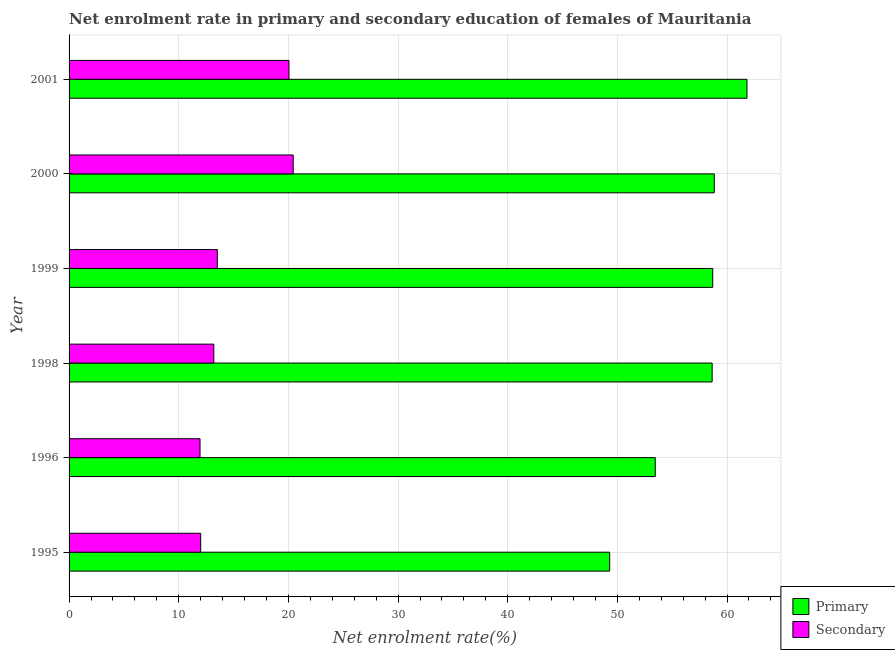Are the number of bars on each tick of the Y-axis equal?
Offer a terse response. Yes. How many bars are there on the 6th tick from the top?
Make the answer very short. 2. What is the label of the 3rd group of bars from the top?
Make the answer very short. 1999. In how many cases, is the number of bars for a given year not equal to the number of legend labels?
Provide a short and direct response. 0. What is the enrollment rate in primary education in 2000?
Provide a short and direct response. 58.84. Across all years, what is the maximum enrollment rate in primary education?
Provide a short and direct response. 61.82. Across all years, what is the minimum enrollment rate in secondary education?
Make the answer very short. 11.94. In which year was the enrollment rate in primary education maximum?
Offer a very short reply. 2001. In which year was the enrollment rate in primary education minimum?
Give a very brief answer. 1995. What is the total enrollment rate in secondary education in the graph?
Provide a short and direct response. 91.15. What is the difference between the enrollment rate in secondary education in 1999 and that in 2001?
Ensure brevity in your answer.  -6.54. What is the difference between the enrollment rate in primary education in 1999 and the enrollment rate in secondary education in 2001?
Offer a very short reply. 38.64. What is the average enrollment rate in primary education per year?
Offer a terse response. 56.79. In the year 1996, what is the difference between the enrollment rate in primary education and enrollment rate in secondary education?
Provide a succinct answer. 41.51. What is the ratio of the enrollment rate in secondary education in 2000 to that in 2001?
Give a very brief answer. 1.02. Is the enrollment rate in primary education in 1995 less than that in 2000?
Make the answer very short. Yes. What is the difference between the highest and the second highest enrollment rate in secondary education?
Offer a very short reply. 0.38. What is the difference between the highest and the lowest enrollment rate in primary education?
Make the answer very short. 12.52. In how many years, is the enrollment rate in secondary education greater than the average enrollment rate in secondary education taken over all years?
Ensure brevity in your answer.  2. What does the 2nd bar from the top in 1998 represents?
Offer a very short reply. Primary. What does the 2nd bar from the bottom in 2001 represents?
Offer a terse response. Secondary. How many bars are there?
Keep it short and to the point. 12. Are all the bars in the graph horizontal?
Offer a very short reply. Yes. How many years are there in the graph?
Offer a very short reply. 6. What is the difference between two consecutive major ticks on the X-axis?
Make the answer very short. 10. Where does the legend appear in the graph?
Provide a succinct answer. Bottom right. How many legend labels are there?
Your answer should be very brief. 2. What is the title of the graph?
Your answer should be very brief. Net enrolment rate in primary and secondary education of females of Mauritania. Does "GDP" appear as one of the legend labels in the graph?
Offer a very short reply. No. What is the label or title of the X-axis?
Your answer should be compact. Net enrolment rate(%). What is the Net enrolment rate(%) in Primary in 1995?
Keep it short and to the point. 49.3. What is the Net enrolment rate(%) of Secondary in 1995?
Provide a succinct answer. 12. What is the Net enrolment rate(%) in Primary in 1996?
Your answer should be compact. 53.45. What is the Net enrolment rate(%) of Secondary in 1996?
Your response must be concise. 11.94. What is the Net enrolment rate(%) of Primary in 1998?
Your response must be concise. 58.64. What is the Net enrolment rate(%) in Secondary in 1998?
Your answer should be very brief. 13.2. What is the Net enrolment rate(%) in Primary in 1999?
Your answer should be very brief. 58.69. What is the Net enrolment rate(%) of Secondary in 1999?
Keep it short and to the point. 13.52. What is the Net enrolment rate(%) in Primary in 2000?
Your response must be concise. 58.84. What is the Net enrolment rate(%) of Secondary in 2000?
Your answer should be compact. 20.44. What is the Net enrolment rate(%) in Primary in 2001?
Keep it short and to the point. 61.82. What is the Net enrolment rate(%) in Secondary in 2001?
Keep it short and to the point. 20.05. Across all years, what is the maximum Net enrolment rate(%) in Primary?
Your answer should be very brief. 61.82. Across all years, what is the maximum Net enrolment rate(%) in Secondary?
Provide a short and direct response. 20.44. Across all years, what is the minimum Net enrolment rate(%) in Primary?
Keep it short and to the point. 49.3. Across all years, what is the minimum Net enrolment rate(%) of Secondary?
Offer a very short reply. 11.94. What is the total Net enrolment rate(%) of Primary in the graph?
Provide a succinct answer. 340.73. What is the total Net enrolment rate(%) of Secondary in the graph?
Offer a very short reply. 91.15. What is the difference between the Net enrolment rate(%) in Primary in 1995 and that in 1996?
Give a very brief answer. -4.16. What is the difference between the Net enrolment rate(%) in Secondary in 1995 and that in 1996?
Offer a terse response. 0.06. What is the difference between the Net enrolment rate(%) of Primary in 1995 and that in 1998?
Your response must be concise. -9.34. What is the difference between the Net enrolment rate(%) in Secondary in 1995 and that in 1998?
Provide a succinct answer. -1.2. What is the difference between the Net enrolment rate(%) of Primary in 1995 and that in 1999?
Give a very brief answer. -9.4. What is the difference between the Net enrolment rate(%) of Secondary in 1995 and that in 1999?
Offer a very short reply. -1.51. What is the difference between the Net enrolment rate(%) of Primary in 1995 and that in 2000?
Keep it short and to the point. -9.54. What is the difference between the Net enrolment rate(%) in Secondary in 1995 and that in 2000?
Offer a very short reply. -8.44. What is the difference between the Net enrolment rate(%) of Primary in 1995 and that in 2001?
Make the answer very short. -12.52. What is the difference between the Net enrolment rate(%) of Secondary in 1995 and that in 2001?
Your response must be concise. -8.05. What is the difference between the Net enrolment rate(%) in Primary in 1996 and that in 1998?
Offer a terse response. -5.19. What is the difference between the Net enrolment rate(%) of Secondary in 1996 and that in 1998?
Give a very brief answer. -1.26. What is the difference between the Net enrolment rate(%) of Primary in 1996 and that in 1999?
Ensure brevity in your answer.  -5.24. What is the difference between the Net enrolment rate(%) of Secondary in 1996 and that in 1999?
Provide a short and direct response. -1.57. What is the difference between the Net enrolment rate(%) in Primary in 1996 and that in 2000?
Provide a succinct answer. -5.38. What is the difference between the Net enrolment rate(%) in Secondary in 1996 and that in 2000?
Offer a very short reply. -8.49. What is the difference between the Net enrolment rate(%) in Primary in 1996 and that in 2001?
Your response must be concise. -8.36. What is the difference between the Net enrolment rate(%) of Secondary in 1996 and that in 2001?
Your answer should be compact. -8.11. What is the difference between the Net enrolment rate(%) in Primary in 1998 and that in 1999?
Make the answer very short. -0.05. What is the difference between the Net enrolment rate(%) in Secondary in 1998 and that in 1999?
Keep it short and to the point. -0.32. What is the difference between the Net enrolment rate(%) in Primary in 1998 and that in 2000?
Keep it short and to the point. -0.2. What is the difference between the Net enrolment rate(%) of Secondary in 1998 and that in 2000?
Offer a very short reply. -7.24. What is the difference between the Net enrolment rate(%) of Primary in 1998 and that in 2001?
Provide a succinct answer. -3.18. What is the difference between the Net enrolment rate(%) in Secondary in 1998 and that in 2001?
Your answer should be compact. -6.85. What is the difference between the Net enrolment rate(%) in Primary in 1999 and that in 2000?
Provide a succinct answer. -0.14. What is the difference between the Net enrolment rate(%) of Secondary in 1999 and that in 2000?
Offer a terse response. -6.92. What is the difference between the Net enrolment rate(%) in Primary in 1999 and that in 2001?
Offer a very short reply. -3.12. What is the difference between the Net enrolment rate(%) of Secondary in 1999 and that in 2001?
Make the answer very short. -6.54. What is the difference between the Net enrolment rate(%) of Primary in 2000 and that in 2001?
Offer a terse response. -2.98. What is the difference between the Net enrolment rate(%) in Secondary in 2000 and that in 2001?
Ensure brevity in your answer.  0.38. What is the difference between the Net enrolment rate(%) of Primary in 1995 and the Net enrolment rate(%) of Secondary in 1996?
Your response must be concise. 37.35. What is the difference between the Net enrolment rate(%) of Primary in 1995 and the Net enrolment rate(%) of Secondary in 1998?
Your response must be concise. 36.1. What is the difference between the Net enrolment rate(%) of Primary in 1995 and the Net enrolment rate(%) of Secondary in 1999?
Ensure brevity in your answer.  35.78. What is the difference between the Net enrolment rate(%) of Primary in 1995 and the Net enrolment rate(%) of Secondary in 2000?
Give a very brief answer. 28.86. What is the difference between the Net enrolment rate(%) in Primary in 1995 and the Net enrolment rate(%) in Secondary in 2001?
Keep it short and to the point. 29.24. What is the difference between the Net enrolment rate(%) in Primary in 1996 and the Net enrolment rate(%) in Secondary in 1998?
Your answer should be compact. 40.25. What is the difference between the Net enrolment rate(%) in Primary in 1996 and the Net enrolment rate(%) in Secondary in 1999?
Keep it short and to the point. 39.94. What is the difference between the Net enrolment rate(%) in Primary in 1996 and the Net enrolment rate(%) in Secondary in 2000?
Your answer should be very brief. 33.02. What is the difference between the Net enrolment rate(%) of Primary in 1996 and the Net enrolment rate(%) of Secondary in 2001?
Give a very brief answer. 33.4. What is the difference between the Net enrolment rate(%) in Primary in 1998 and the Net enrolment rate(%) in Secondary in 1999?
Your answer should be compact. 45.12. What is the difference between the Net enrolment rate(%) of Primary in 1998 and the Net enrolment rate(%) of Secondary in 2000?
Provide a short and direct response. 38.2. What is the difference between the Net enrolment rate(%) in Primary in 1998 and the Net enrolment rate(%) in Secondary in 2001?
Offer a terse response. 38.59. What is the difference between the Net enrolment rate(%) of Primary in 1999 and the Net enrolment rate(%) of Secondary in 2000?
Offer a terse response. 38.26. What is the difference between the Net enrolment rate(%) in Primary in 1999 and the Net enrolment rate(%) in Secondary in 2001?
Provide a succinct answer. 38.64. What is the difference between the Net enrolment rate(%) in Primary in 2000 and the Net enrolment rate(%) in Secondary in 2001?
Give a very brief answer. 38.78. What is the average Net enrolment rate(%) in Primary per year?
Ensure brevity in your answer.  56.79. What is the average Net enrolment rate(%) in Secondary per year?
Offer a very short reply. 15.19. In the year 1995, what is the difference between the Net enrolment rate(%) of Primary and Net enrolment rate(%) of Secondary?
Your answer should be very brief. 37.29. In the year 1996, what is the difference between the Net enrolment rate(%) in Primary and Net enrolment rate(%) in Secondary?
Provide a short and direct response. 41.51. In the year 1998, what is the difference between the Net enrolment rate(%) in Primary and Net enrolment rate(%) in Secondary?
Offer a very short reply. 45.44. In the year 1999, what is the difference between the Net enrolment rate(%) of Primary and Net enrolment rate(%) of Secondary?
Make the answer very short. 45.18. In the year 2000, what is the difference between the Net enrolment rate(%) of Primary and Net enrolment rate(%) of Secondary?
Give a very brief answer. 38.4. In the year 2001, what is the difference between the Net enrolment rate(%) of Primary and Net enrolment rate(%) of Secondary?
Offer a very short reply. 41.76. What is the ratio of the Net enrolment rate(%) in Primary in 1995 to that in 1996?
Your answer should be very brief. 0.92. What is the ratio of the Net enrolment rate(%) of Secondary in 1995 to that in 1996?
Ensure brevity in your answer.  1. What is the ratio of the Net enrolment rate(%) in Primary in 1995 to that in 1998?
Your answer should be compact. 0.84. What is the ratio of the Net enrolment rate(%) in Secondary in 1995 to that in 1998?
Your response must be concise. 0.91. What is the ratio of the Net enrolment rate(%) of Primary in 1995 to that in 1999?
Your answer should be very brief. 0.84. What is the ratio of the Net enrolment rate(%) of Secondary in 1995 to that in 1999?
Your response must be concise. 0.89. What is the ratio of the Net enrolment rate(%) of Primary in 1995 to that in 2000?
Ensure brevity in your answer.  0.84. What is the ratio of the Net enrolment rate(%) in Secondary in 1995 to that in 2000?
Ensure brevity in your answer.  0.59. What is the ratio of the Net enrolment rate(%) of Primary in 1995 to that in 2001?
Provide a short and direct response. 0.8. What is the ratio of the Net enrolment rate(%) of Secondary in 1995 to that in 2001?
Provide a short and direct response. 0.6. What is the ratio of the Net enrolment rate(%) of Primary in 1996 to that in 1998?
Make the answer very short. 0.91. What is the ratio of the Net enrolment rate(%) in Secondary in 1996 to that in 1998?
Provide a succinct answer. 0.9. What is the ratio of the Net enrolment rate(%) in Primary in 1996 to that in 1999?
Offer a very short reply. 0.91. What is the ratio of the Net enrolment rate(%) of Secondary in 1996 to that in 1999?
Provide a succinct answer. 0.88. What is the ratio of the Net enrolment rate(%) in Primary in 1996 to that in 2000?
Offer a very short reply. 0.91. What is the ratio of the Net enrolment rate(%) in Secondary in 1996 to that in 2000?
Provide a short and direct response. 0.58. What is the ratio of the Net enrolment rate(%) of Primary in 1996 to that in 2001?
Your response must be concise. 0.86. What is the ratio of the Net enrolment rate(%) of Secondary in 1996 to that in 2001?
Make the answer very short. 0.6. What is the ratio of the Net enrolment rate(%) of Primary in 1998 to that in 1999?
Provide a short and direct response. 1. What is the ratio of the Net enrolment rate(%) in Secondary in 1998 to that in 1999?
Your answer should be very brief. 0.98. What is the ratio of the Net enrolment rate(%) of Primary in 1998 to that in 2000?
Make the answer very short. 1. What is the ratio of the Net enrolment rate(%) of Secondary in 1998 to that in 2000?
Offer a very short reply. 0.65. What is the ratio of the Net enrolment rate(%) in Primary in 1998 to that in 2001?
Give a very brief answer. 0.95. What is the ratio of the Net enrolment rate(%) of Secondary in 1998 to that in 2001?
Ensure brevity in your answer.  0.66. What is the ratio of the Net enrolment rate(%) in Primary in 1999 to that in 2000?
Give a very brief answer. 1. What is the ratio of the Net enrolment rate(%) in Secondary in 1999 to that in 2000?
Give a very brief answer. 0.66. What is the ratio of the Net enrolment rate(%) in Primary in 1999 to that in 2001?
Your answer should be very brief. 0.95. What is the ratio of the Net enrolment rate(%) in Secondary in 1999 to that in 2001?
Ensure brevity in your answer.  0.67. What is the ratio of the Net enrolment rate(%) in Primary in 2000 to that in 2001?
Offer a very short reply. 0.95. What is the ratio of the Net enrolment rate(%) of Secondary in 2000 to that in 2001?
Your answer should be very brief. 1.02. What is the difference between the highest and the second highest Net enrolment rate(%) in Primary?
Ensure brevity in your answer.  2.98. What is the difference between the highest and the second highest Net enrolment rate(%) in Secondary?
Provide a succinct answer. 0.38. What is the difference between the highest and the lowest Net enrolment rate(%) of Primary?
Offer a very short reply. 12.52. What is the difference between the highest and the lowest Net enrolment rate(%) in Secondary?
Offer a terse response. 8.49. 